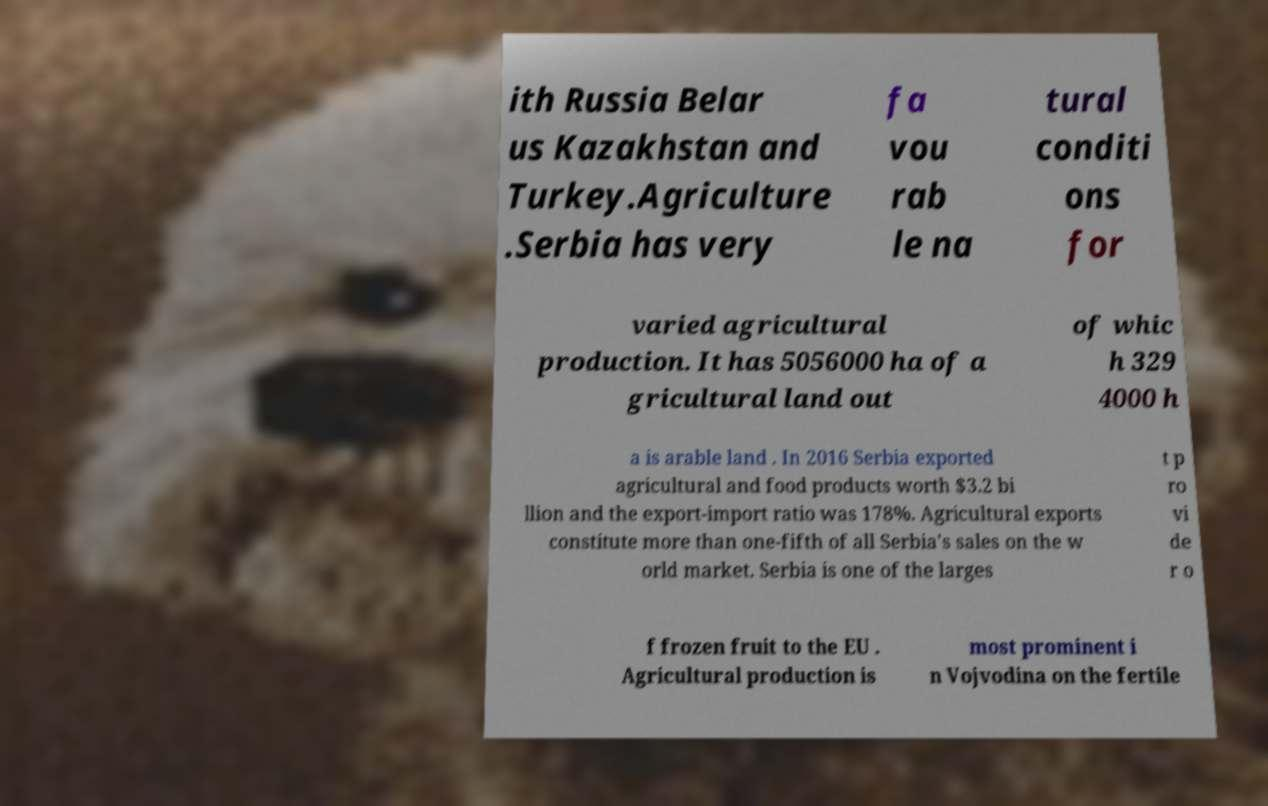I need the written content from this picture converted into text. Can you do that? ith Russia Belar us Kazakhstan and Turkey.Agriculture .Serbia has very fa vou rab le na tural conditi ons for varied agricultural production. It has 5056000 ha of a gricultural land out of whic h 329 4000 h a is arable land . In 2016 Serbia exported agricultural and food products worth $3.2 bi llion and the export-import ratio was 178%. Agricultural exports constitute more than one-fifth of all Serbia's sales on the w orld market. Serbia is one of the larges t p ro vi de r o f frozen fruit to the EU . Agricultural production is most prominent i n Vojvodina on the fertile 